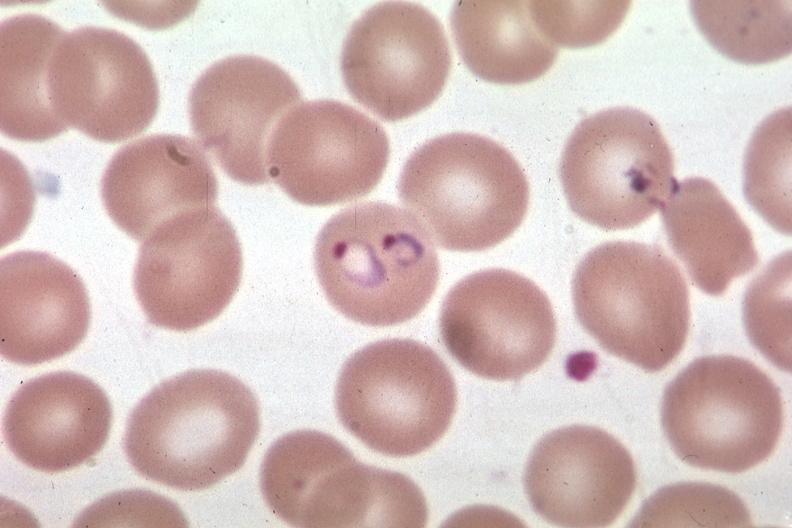s retroperitoneal liposarcoma present?
Answer the question using a single word or phrase. No 